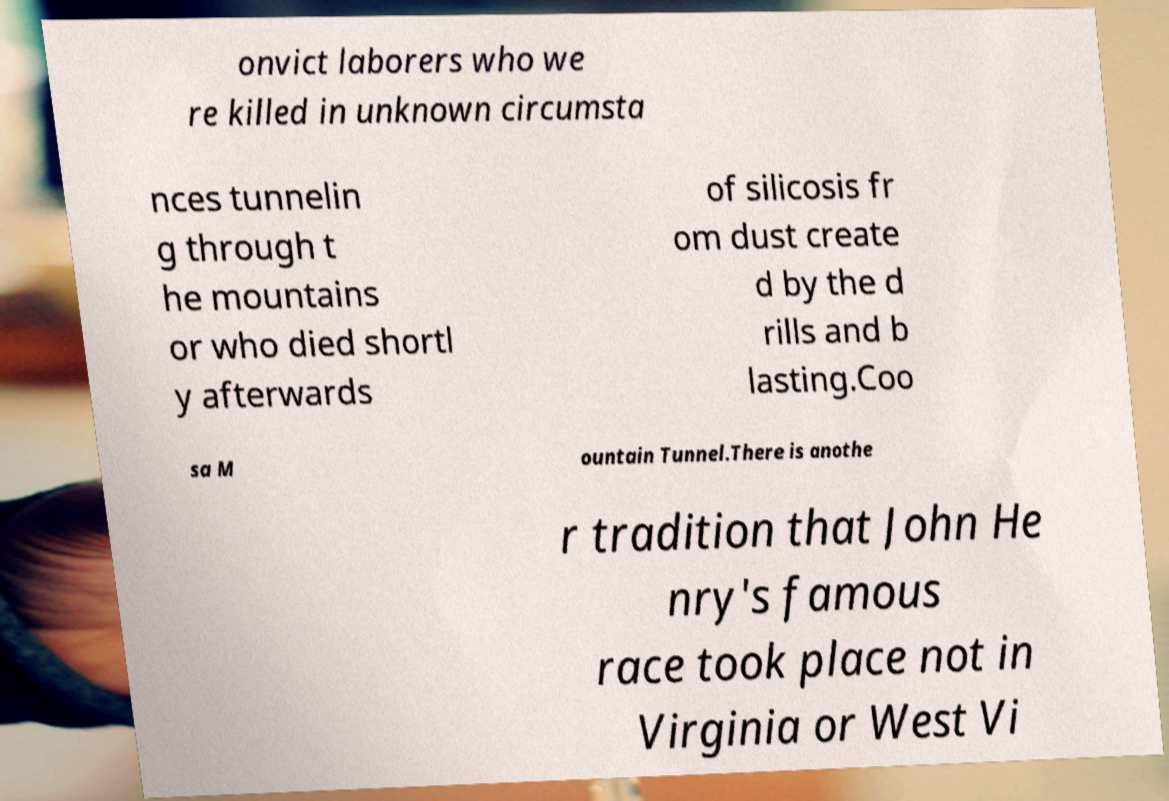I need the written content from this picture converted into text. Can you do that? onvict laborers who we re killed in unknown circumsta nces tunnelin g through t he mountains or who died shortl y afterwards of silicosis fr om dust create d by the d rills and b lasting.Coo sa M ountain Tunnel.There is anothe r tradition that John He nry's famous race took place not in Virginia or West Vi 